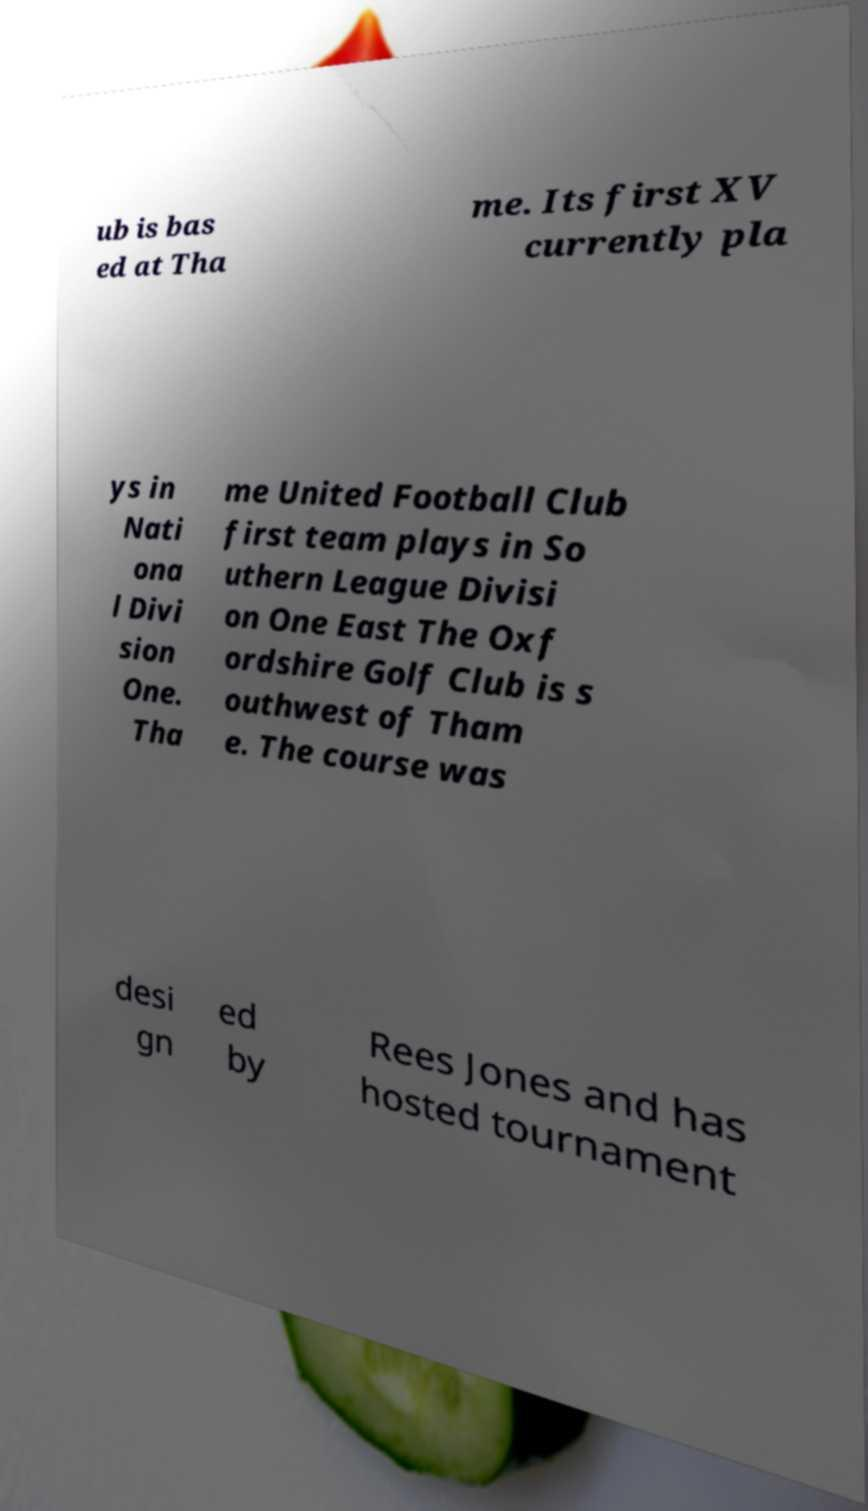Please identify and transcribe the text found in this image. ub is bas ed at Tha me. Its first XV currently pla ys in Nati ona l Divi sion One. Tha me United Football Club first team plays in So uthern League Divisi on One East The Oxf ordshire Golf Club is s outhwest of Tham e. The course was desi gn ed by Rees Jones and has hosted tournament 